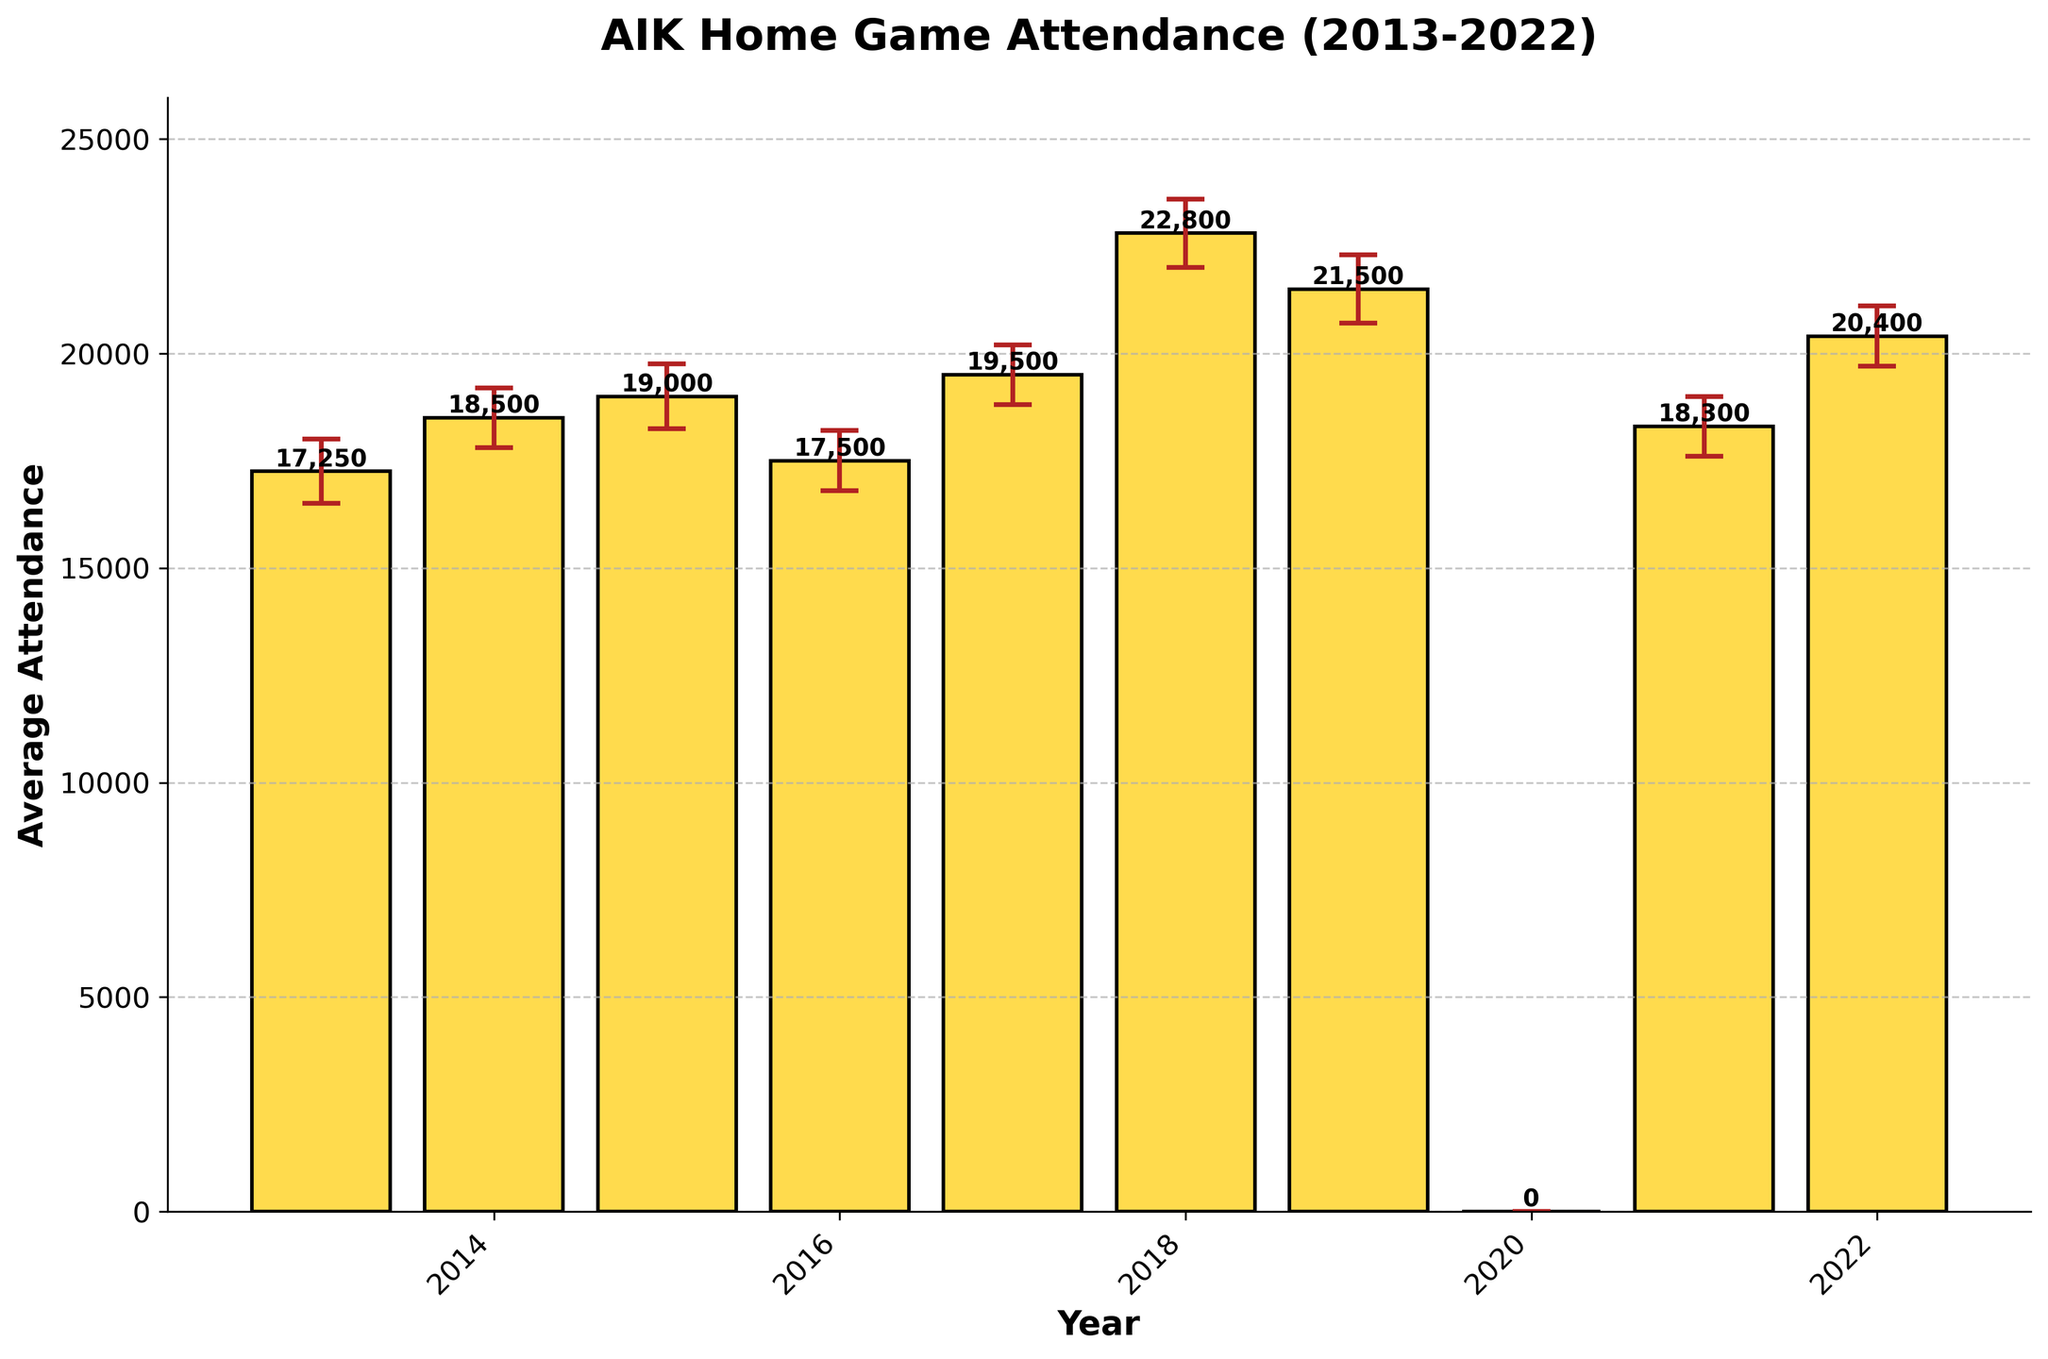what is the average attendance for AIK home games in 2018? To find the average attendance for AIK home games in 2018, look at the bar corresponding to 2018 on the x-axis. The height of the bar represents the average attendance.
Answer: 22,800 what is the range of the error bars for the year 2015? The range of the error bars is the difference between the upper and lower confidence intervals. For 2015, the upper CI is 19,750 and the lower CI is 18,250. The range is 19,750 - 18,250.
Answer: 1,500 how did the average attendance change from 2013 to 2014? To determine the change, subtract the average attendance in 2013 from the average attendance in 2014. The values are 18,500 (2014) minus 17,250 (2013).
Answer: 1,250 increase which year had the highest lower confidence interval? Identify the bar with the highest lower confidence interval. The lower CI are marked by the bottom of the error bar below each average attendance bar.
Answer: 2018 what is the median average attendance from 2013 to 2022? First, list the average attendances in ascending order: 0, 17,250, 17,500, 18,300, 18,500, 19,000, 19,500, 20,400, 21,500, 22,800. The median is the middle value. Since there is an even number of data points, the median is the average of the 5th and 6th values.
Answer: 18,900 how many years had an average attendance greater than 20,000? Count the number of bars where the average attendance (height of the bar) exceeds 20,000.
Answer: 3 years what is the smallest increase in average attendance between consecutive years? Calculate the year-to-year changes and find the smallest positive value. The relevant changes are: 1,250 (2014 over 2013), 500 (2015 over 2014), -1,500 (2016 over 2015), 2,000 (2017 over 2016), 3,300 (2018 over 2017), -1,300 (2019 over 2018), -21,500 (2020 over 2019, anomaly), 18,300 (2021 over 2020), 2,100 (2022 over 2021). The smallest positive value is 500 (2015 over 2014).
Answer: 500 did the average attendance ever fall below 18,000? Look for bars which height (average attendance) are below 18,000. Only the bar for 2020 obviously falls automatically to zero.
Answer: Yes, in 2020 compare the average attendance and its range of error for 2019 and 2022. For 2019 and 2022, note the average attendances and ranges of error (upper CI - lower CI). 2019: average 21,500, range 1,600; 2022: average 20,400, range 1,400.
Answer: 2019: 21,500 with 1,600 range; 2022: 20,400 with 1,400 range which year has the highest average attendance, excluding 2020? Identify the bar with the maximum height, excluding the year 2020 which has zero attendance.
Answer: 2018 